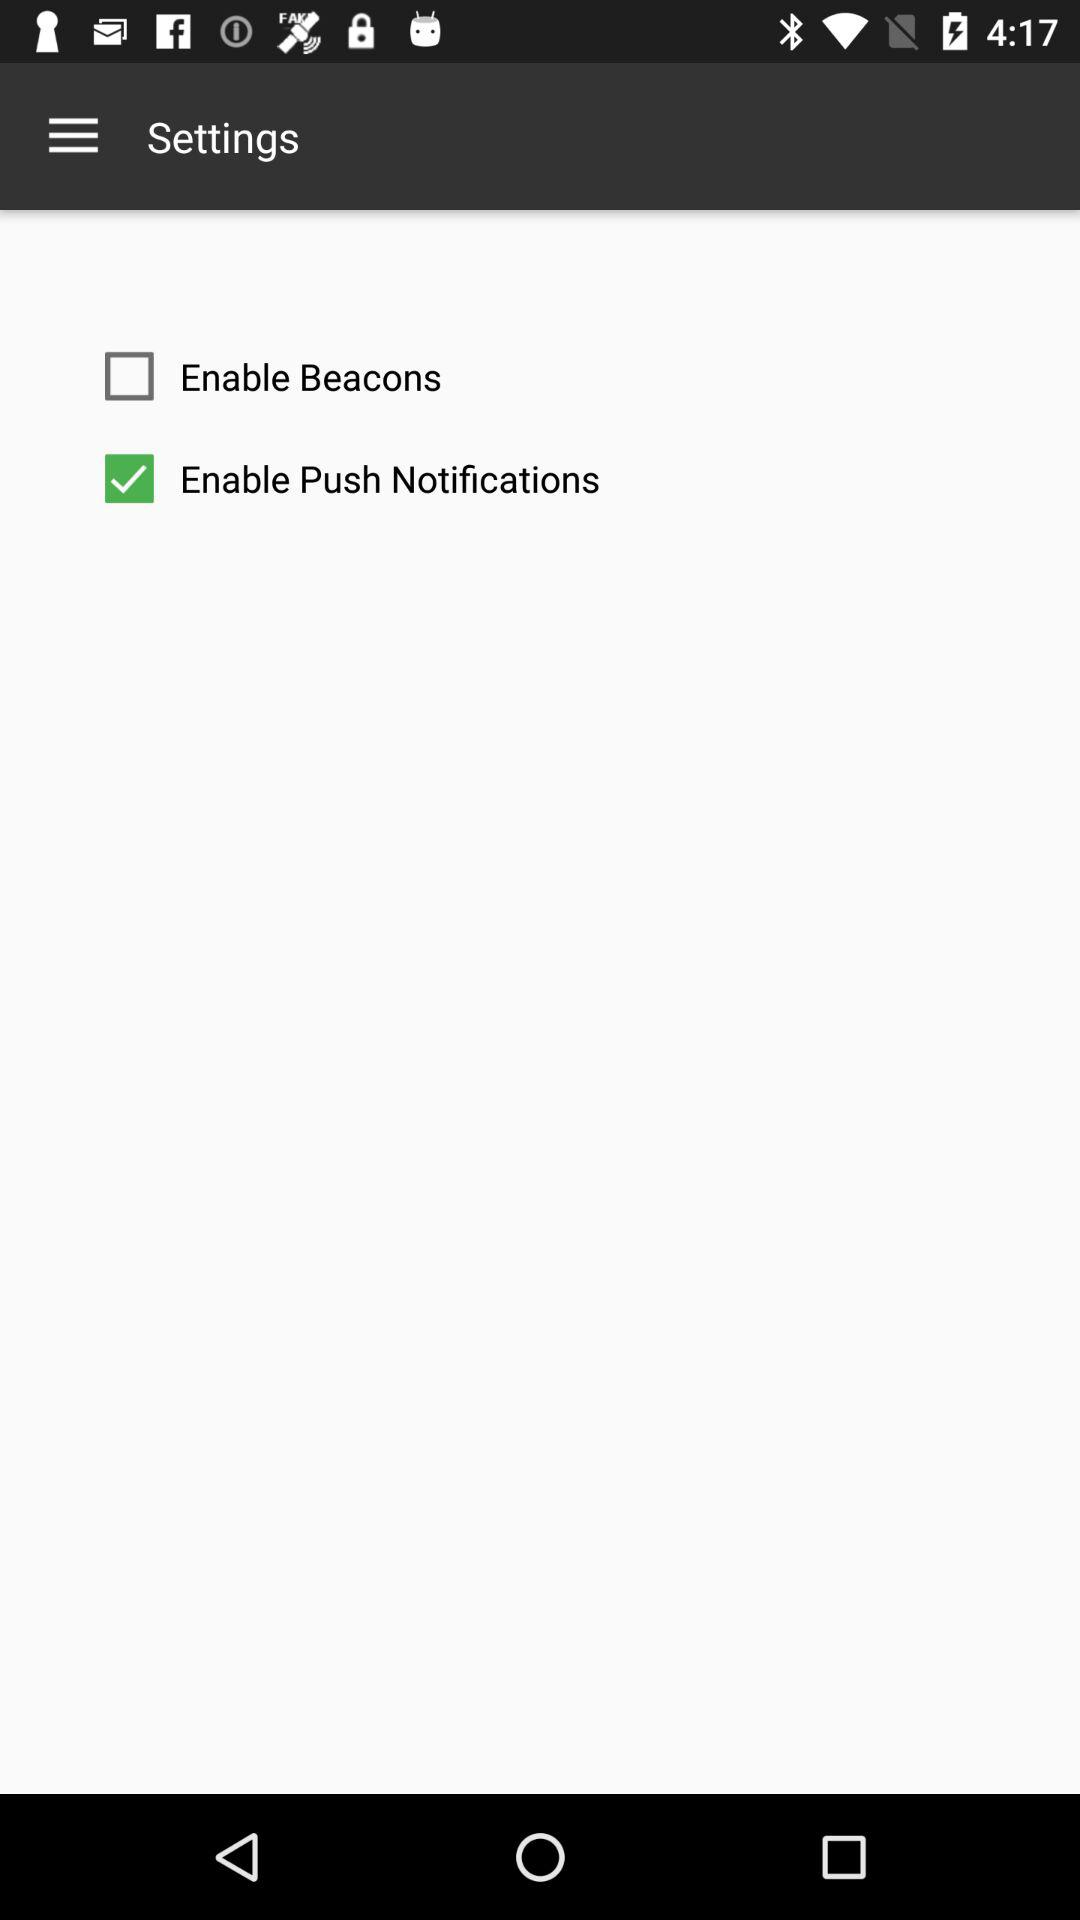What is the status of "Enable Push Notifications"? The status is "on". 